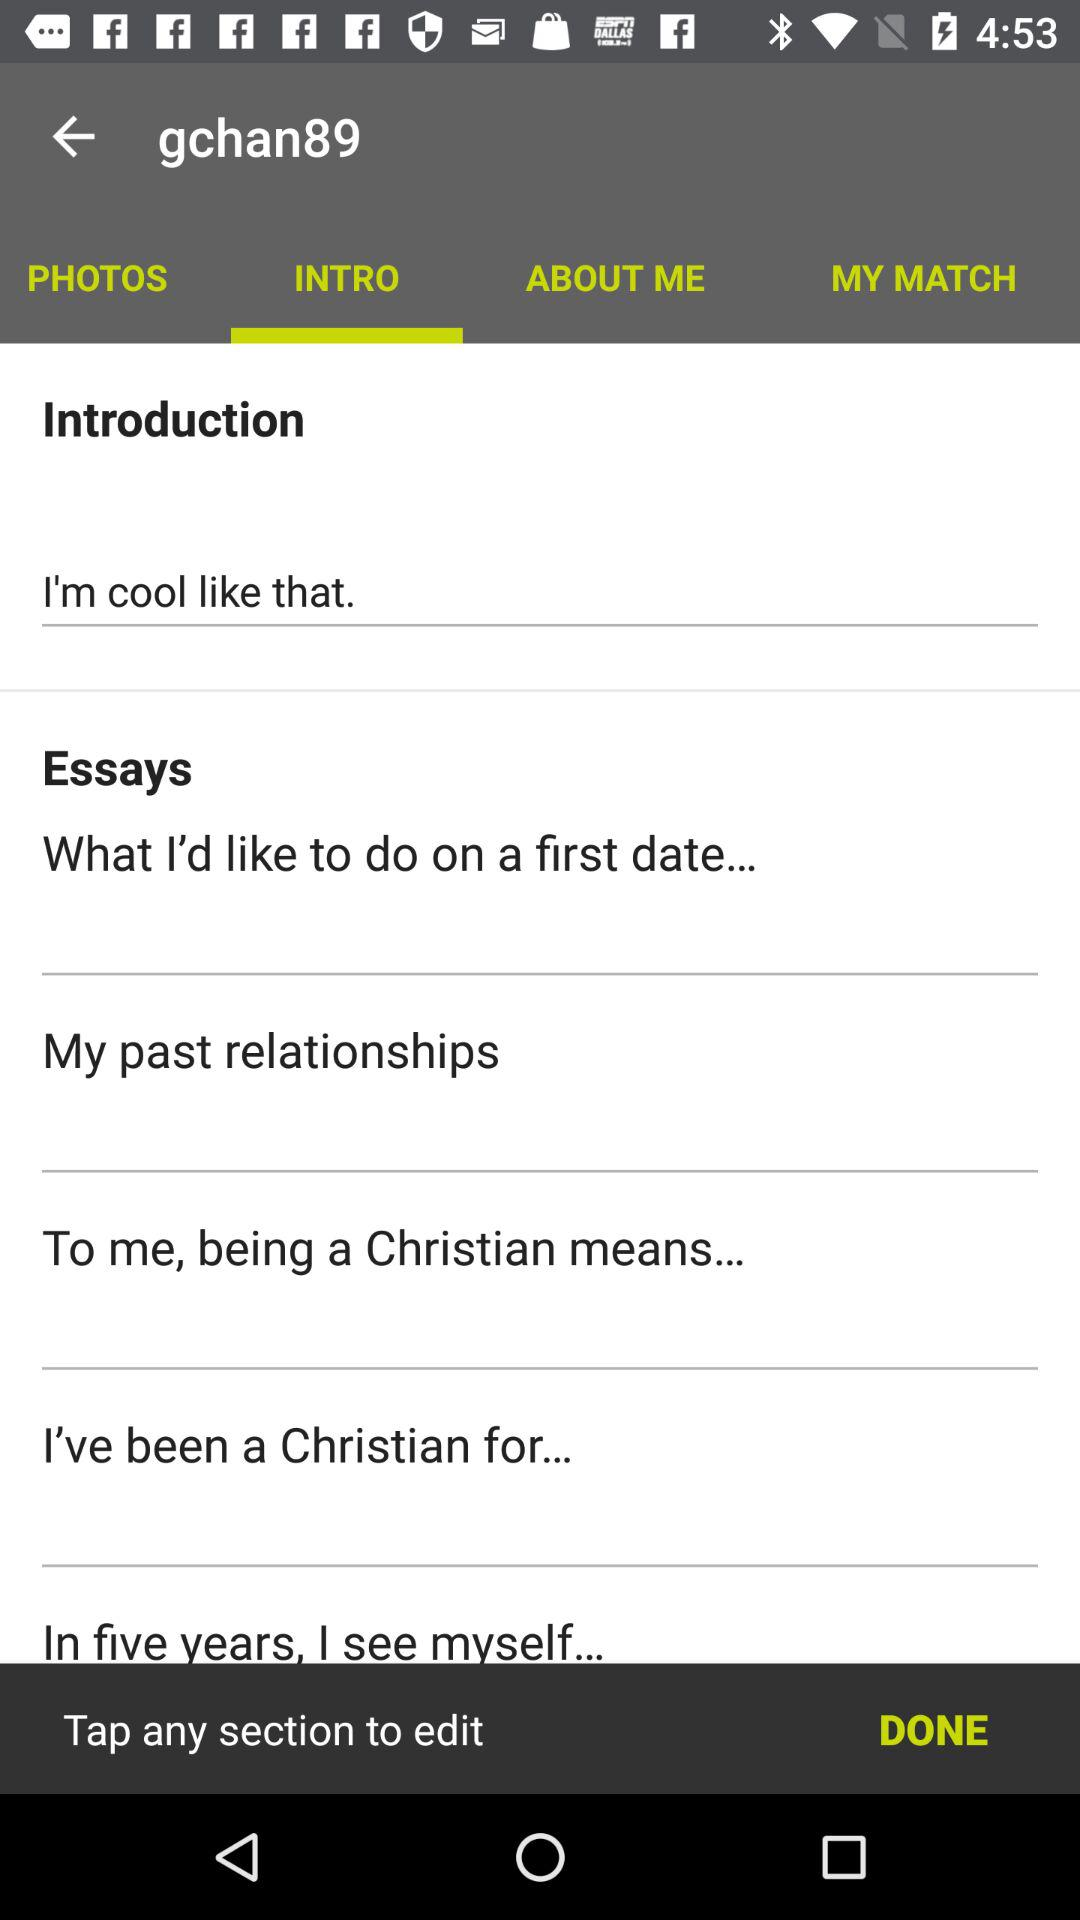What is the introduction? The introduction is "I'm cool like that". 